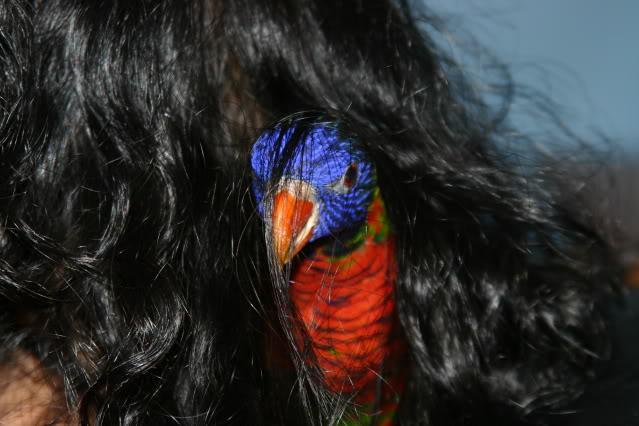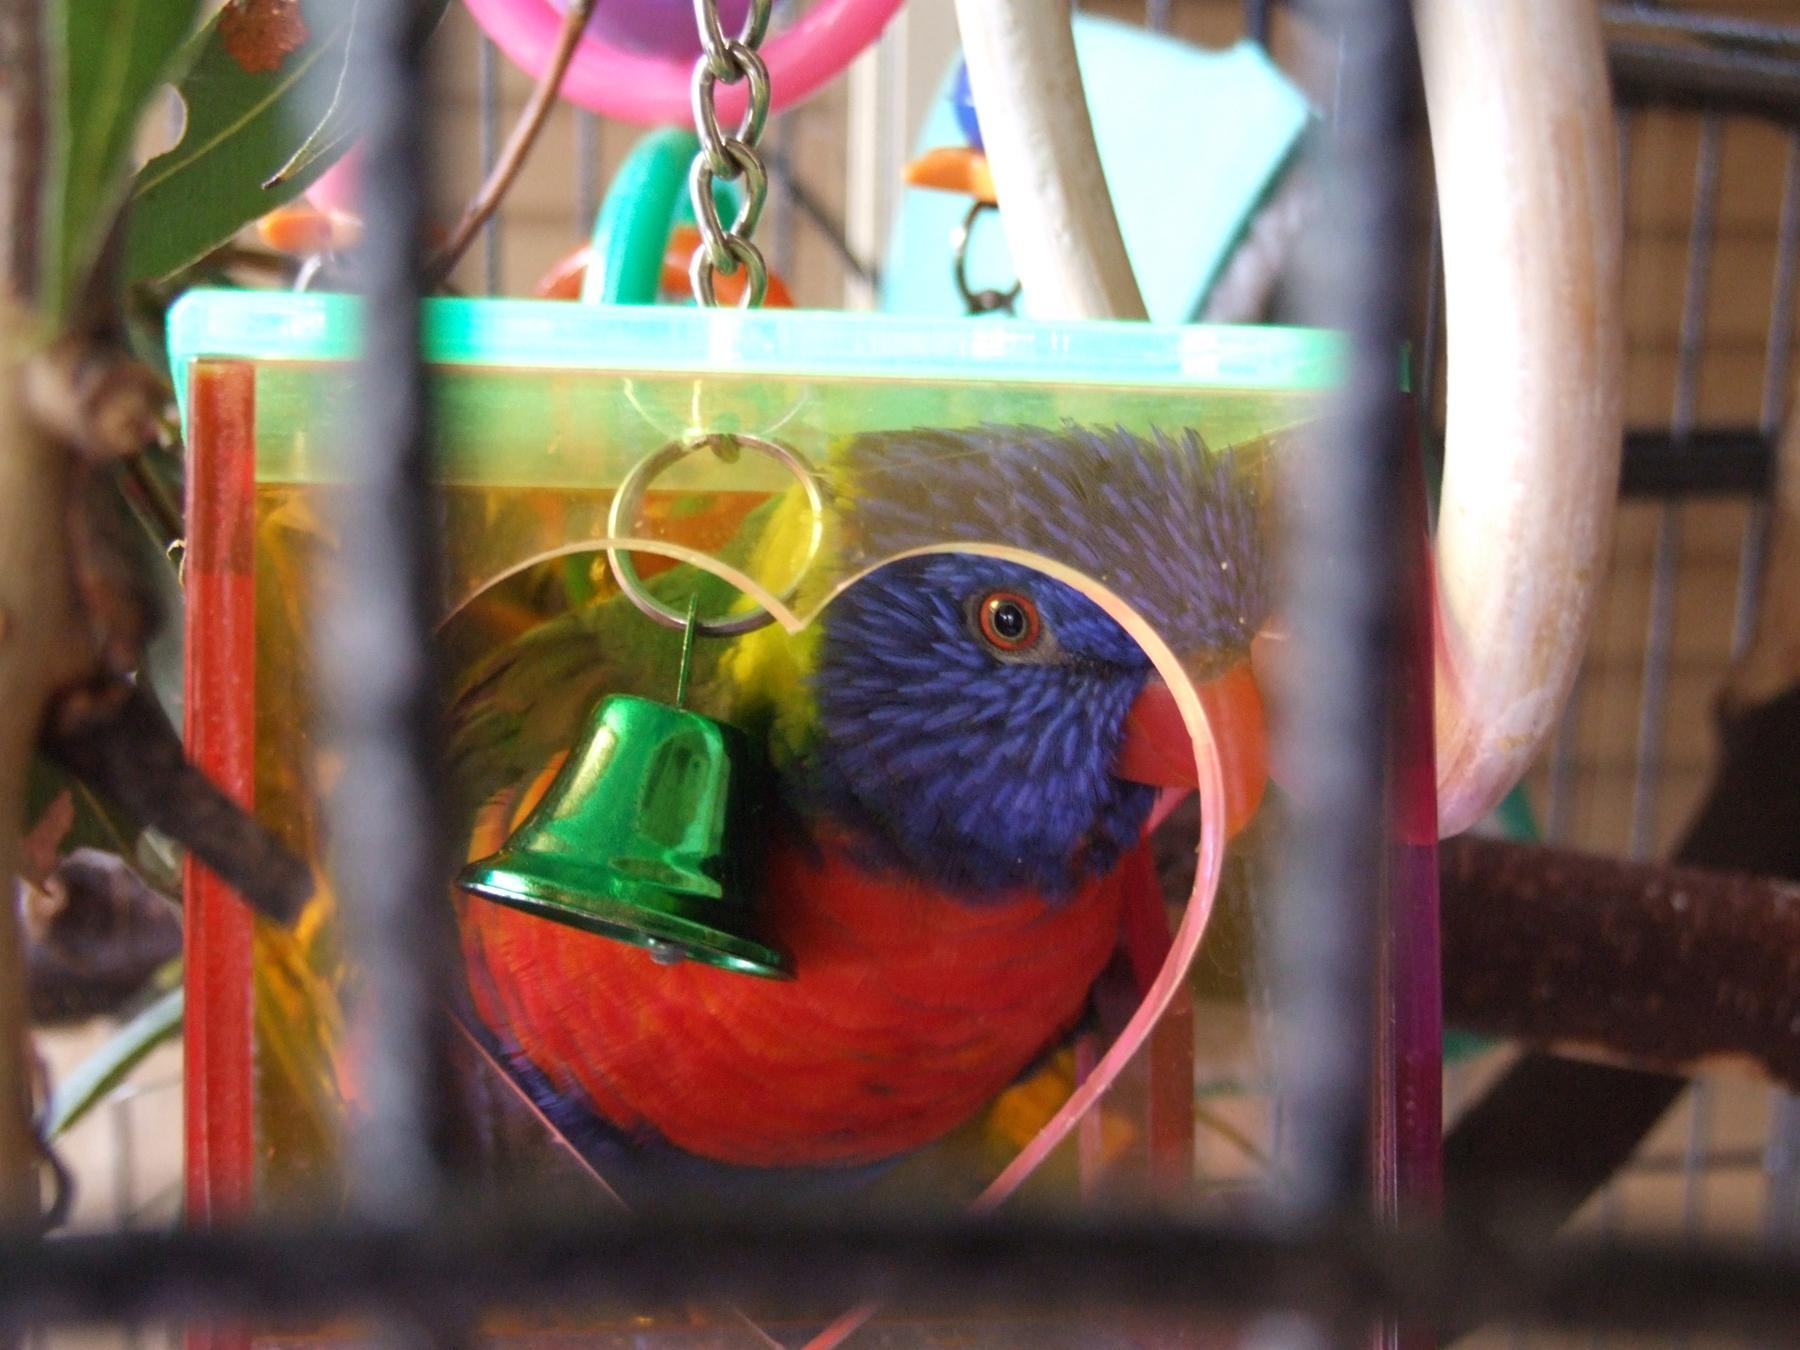The first image is the image on the left, the second image is the image on the right. For the images displayed, is the sentence "A green bird is sitting in a cage in the image on the left." factually correct? Answer yes or no. No. The first image is the image on the left, the second image is the image on the right. Given the left and right images, does the statement "Each image features at least one bird and a wire bird cage." hold true? Answer yes or no. No. 